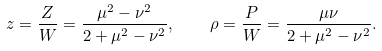<formula> <loc_0><loc_0><loc_500><loc_500>z = \frac { Z } { W } = \frac { \mu ^ { 2 } - \nu ^ { 2 } } { 2 + \mu ^ { 2 } - \nu ^ { 2 } } , \quad \rho = \frac { P } { W } = \frac { \mu \nu } { 2 + \mu ^ { 2 } - \nu ^ { 2 } } .</formula> 